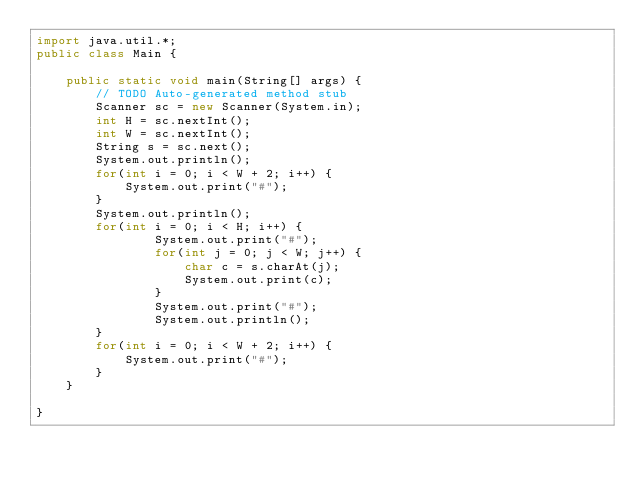<code> <loc_0><loc_0><loc_500><loc_500><_Java_>import java.util.*;
public class Main {
	
	public static void main(String[] args) {
		// TODO Auto-generated method stub
		Scanner sc = new Scanner(System.in);
		int H = sc.nextInt();
		int W = sc.nextInt();
		String s = sc.next();
		System.out.println();
		for(int i = 0; i < W + 2; i++) {
			System.out.print("#");
		}
		System.out.println();
		for(int i = 0; i < H; i++) {
				System.out.print("#");
				for(int j = 0; j < W; j++) {
					char c = s.charAt(j);
					System.out.print(c);
				}
				System.out.print("#");
				System.out.println();
		}
		for(int i = 0; i < W + 2; i++) {
			System.out.print("#");
		}
	}

}</code> 